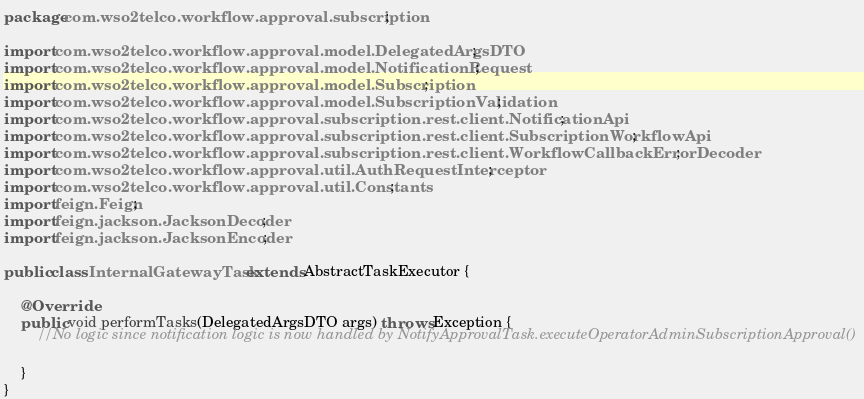<code> <loc_0><loc_0><loc_500><loc_500><_Java_>package com.wso2telco.workflow.approval.subscription;

import com.wso2telco.workflow.approval.model.DelegatedArgsDTO;
import com.wso2telco.workflow.approval.model.NotificationRequest;
import com.wso2telco.workflow.approval.model.Subscription;
import com.wso2telco.workflow.approval.model.SubscriptionValidation;
import com.wso2telco.workflow.approval.subscription.rest.client.NotificationApi;
import com.wso2telco.workflow.approval.subscription.rest.client.SubscriptionWorkflowApi;
import com.wso2telco.workflow.approval.subscription.rest.client.WorkflowCallbackErrorDecoder;
import com.wso2telco.workflow.approval.util.AuthRequestInterceptor;
import com.wso2telco.workflow.approval.util.Constants;
import feign.Feign;
import feign.jackson.JacksonDecoder;
import feign.jackson.JacksonEncoder;

public class InternalGatewayTask extends AbstractTaskExecutor {

    @Override
    public void performTasks(DelegatedArgsDTO args) throws Exception {
        //No logic since notification logic is now handled by NotifyApprovalTask.executeOperatorAdminSubscriptionApproval()

    }
}
</code> 